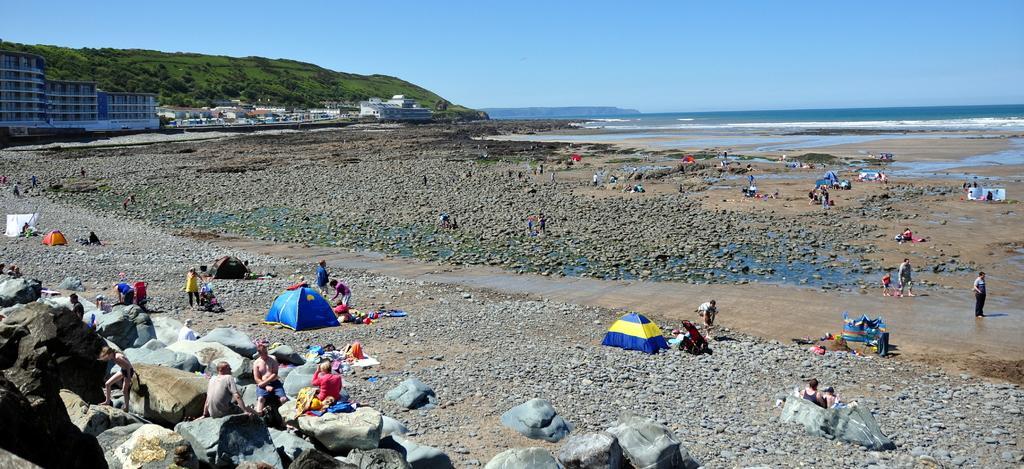Describe this image in one or two sentences. In the left side few people are sitting, there are few tent houses, in the right side it looks like a sea and in the left side there is a big building. In the middle at the top it's a blue color sky. 